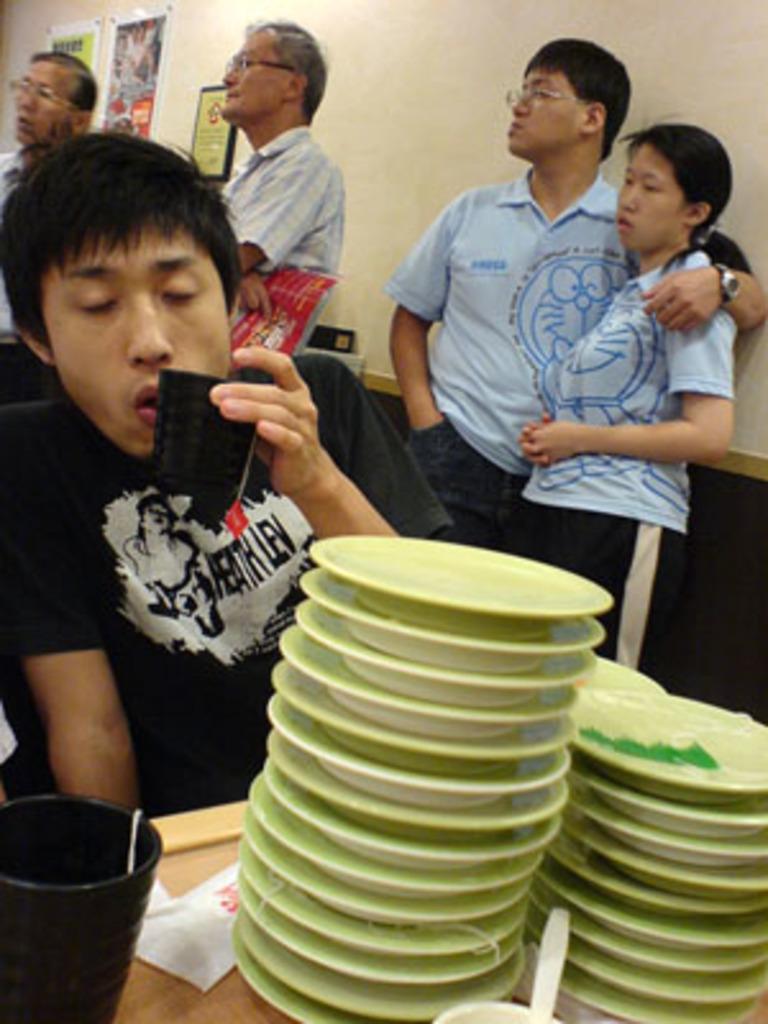How would you summarize this image in a sentence or two? In this image, we can see a man holding cup in his hand and there are some plates and cups along with spoons are placed on the table. In the background, there are some people standing and we can see some frames placed on the wall. 